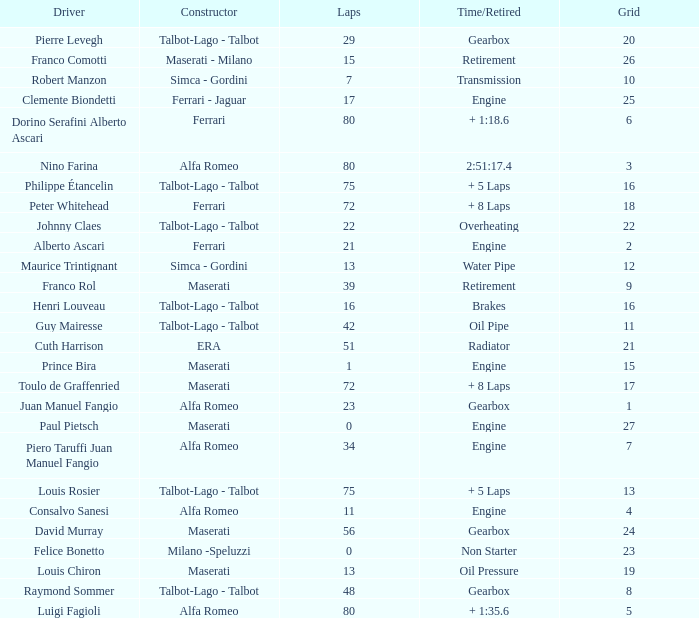What was the smallest grid for Prince bira? 15.0. 